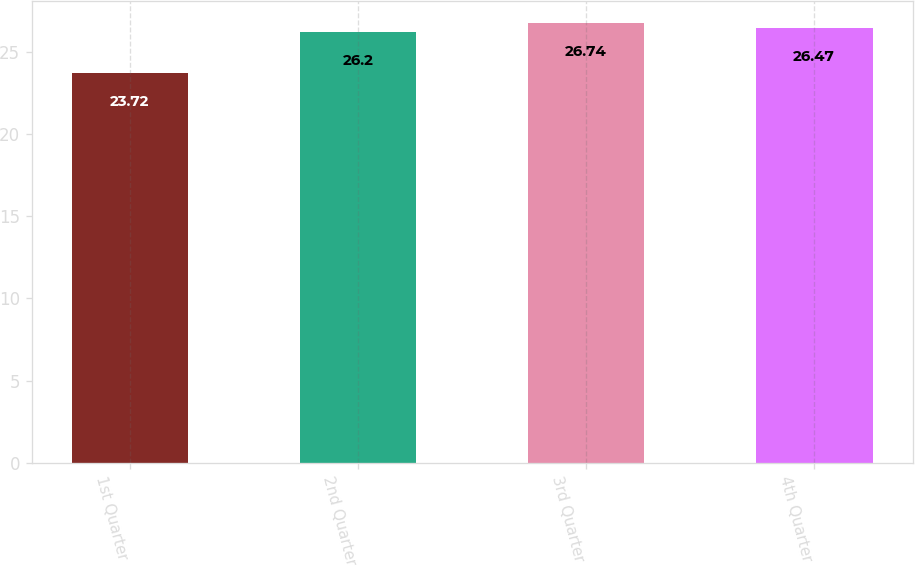Convert chart. <chart><loc_0><loc_0><loc_500><loc_500><bar_chart><fcel>1st Quarter<fcel>2nd Quarter<fcel>3rd Quarter<fcel>4th Quarter<nl><fcel>23.72<fcel>26.2<fcel>26.74<fcel>26.47<nl></chart> 